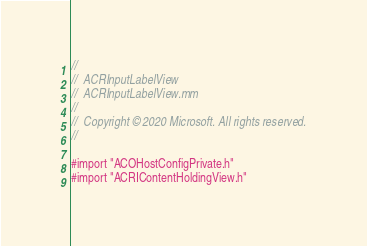Convert code to text. <code><loc_0><loc_0><loc_500><loc_500><_ObjectiveC_>//
//  ACRInputLabelView
//  ACRInputLabelView.mm
//
//  Copyright © 2020 Microsoft. All rights reserved.
//

#import "ACOHostConfigPrivate.h"
#import "ACRIContentHoldingView.h"</code> 